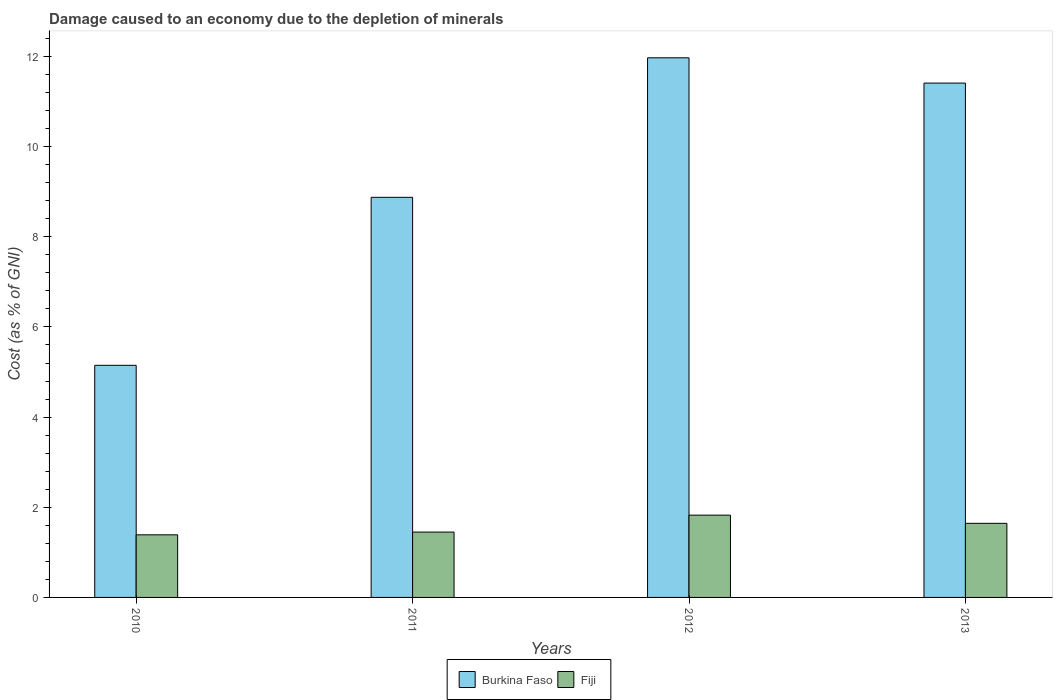Are the number of bars on each tick of the X-axis equal?
Ensure brevity in your answer.  Yes. What is the label of the 1st group of bars from the left?
Make the answer very short. 2010. In how many cases, is the number of bars for a given year not equal to the number of legend labels?
Ensure brevity in your answer.  0. What is the cost of damage caused due to the depletion of minerals in Fiji in 2013?
Provide a short and direct response. 1.64. Across all years, what is the maximum cost of damage caused due to the depletion of minerals in Burkina Faso?
Offer a very short reply. 11.97. Across all years, what is the minimum cost of damage caused due to the depletion of minerals in Fiji?
Your response must be concise. 1.39. In which year was the cost of damage caused due to the depletion of minerals in Burkina Faso maximum?
Keep it short and to the point. 2012. What is the total cost of damage caused due to the depletion of minerals in Fiji in the graph?
Provide a succinct answer. 6.31. What is the difference between the cost of damage caused due to the depletion of minerals in Burkina Faso in 2010 and that in 2012?
Give a very brief answer. -6.82. What is the difference between the cost of damage caused due to the depletion of minerals in Burkina Faso in 2011 and the cost of damage caused due to the depletion of minerals in Fiji in 2012?
Your response must be concise. 7.05. What is the average cost of damage caused due to the depletion of minerals in Burkina Faso per year?
Ensure brevity in your answer.  9.35. In the year 2011, what is the difference between the cost of damage caused due to the depletion of minerals in Fiji and cost of damage caused due to the depletion of minerals in Burkina Faso?
Offer a terse response. -7.43. What is the ratio of the cost of damage caused due to the depletion of minerals in Fiji in 2010 to that in 2012?
Provide a short and direct response. 0.76. Is the cost of damage caused due to the depletion of minerals in Burkina Faso in 2010 less than that in 2012?
Offer a very short reply. Yes. What is the difference between the highest and the second highest cost of damage caused due to the depletion of minerals in Fiji?
Your response must be concise. 0.18. What is the difference between the highest and the lowest cost of damage caused due to the depletion of minerals in Burkina Faso?
Offer a terse response. 6.82. In how many years, is the cost of damage caused due to the depletion of minerals in Burkina Faso greater than the average cost of damage caused due to the depletion of minerals in Burkina Faso taken over all years?
Give a very brief answer. 2. Is the sum of the cost of damage caused due to the depletion of minerals in Fiji in 2012 and 2013 greater than the maximum cost of damage caused due to the depletion of minerals in Burkina Faso across all years?
Your answer should be compact. No. What does the 1st bar from the left in 2013 represents?
Give a very brief answer. Burkina Faso. What does the 2nd bar from the right in 2012 represents?
Your answer should be very brief. Burkina Faso. How many bars are there?
Your response must be concise. 8. Are all the bars in the graph horizontal?
Keep it short and to the point. No. How many years are there in the graph?
Give a very brief answer. 4. Does the graph contain any zero values?
Make the answer very short. No. How are the legend labels stacked?
Provide a short and direct response. Horizontal. What is the title of the graph?
Your answer should be very brief. Damage caused to an economy due to the depletion of minerals. Does "Ireland" appear as one of the legend labels in the graph?
Your answer should be compact. No. What is the label or title of the X-axis?
Keep it short and to the point. Years. What is the label or title of the Y-axis?
Give a very brief answer. Cost (as % of GNI). What is the Cost (as % of GNI) in Burkina Faso in 2010?
Provide a succinct answer. 5.15. What is the Cost (as % of GNI) in Fiji in 2010?
Provide a short and direct response. 1.39. What is the Cost (as % of GNI) in Burkina Faso in 2011?
Give a very brief answer. 8.88. What is the Cost (as % of GNI) in Fiji in 2011?
Your answer should be very brief. 1.45. What is the Cost (as % of GNI) in Burkina Faso in 2012?
Your answer should be very brief. 11.97. What is the Cost (as % of GNI) of Fiji in 2012?
Provide a short and direct response. 1.83. What is the Cost (as % of GNI) of Burkina Faso in 2013?
Keep it short and to the point. 11.41. What is the Cost (as % of GNI) of Fiji in 2013?
Provide a short and direct response. 1.64. Across all years, what is the maximum Cost (as % of GNI) of Burkina Faso?
Provide a short and direct response. 11.97. Across all years, what is the maximum Cost (as % of GNI) of Fiji?
Keep it short and to the point. 1.83. Across all years, what is the minimum Cost (as % of GNI) of Burkina Faso?
Give a very brief answer. 5.15. Across all years, what is the minimum Cost (as % of GNI) in Fiji?
Your answer should be very brief. 1.39. What is the total Cost (as % of GNI) of Burkina Faso in the graph?
Keep it short and to the point. 37.4. What is the total Cost (as % of GNI) in Fiji in the graph?
Provide a short and direct response. 6.31. What is the difference between the Cost (as % of GNI) of Burkina Faso in 2010 and that in 2011?
Offer a terse response. -3.73. What is the difference between the Cost (as % of GNI) of Fiji in 2010 and that in 2011?
Give a very brief answer. -0.06. What is the difference between the Cost (as % of GNI) in Burkina Faso in 2010 and that in 2012?
Give a very brief answer. -6.82. What is the difference between the Cost (as % of GNI) of Fiji in 2010 and that in 2012?
Keep it short and to the point. -0.44. What is the difference between the Cost (as % of GNI) of Burkina Faso in 2010 and that in 2013?
Offer a terse response. -6.26. What is the difference between the Cost (as % of GNI) of Fiji in 2010 and that in 2013?
Offer a very short reply. -0.25. What is the difference between the Cost (as % of GNI) of Burkina Faso in 2011 and that in 2012?
Provide a short and direct response. -3.09. What is the difference between the Cost (as % of GNI) in Fiji in 2011 and that in 2012?
Your answer should be very brief. -0.38. What is the difference between the Cost (as % of GNI) of Burkina Faso in 2011 and that in 2013?
Make the answer very short. -2.53. What is the difference between the Cost (as % of GNI) of Fiji in 2011 and that in 2013?
Your response must be concise. -0.19. What is the difference between the Cost (as % of GNI) of Burkina Faso in 2012 and that in 2013?
Ensure brevity in your answer.  0.56. What is the difference between the Cost (as % of GNI) of Fiji in 2012 and that in 2013?
Ensure brevity in your answer.  0.18. What is the difference between the Cost (as % of GNI) of Burkina Faso in 2010 and the Cost (as % of GNI) of Fiji in 2011?
Your response must be concise. 3.7. What is the difference between the Cost (as % of GNI) in Burkina Faso in 2010 and the Cost (as % of GNI) in Fiji in 2012?
Provide a short and direct response. 3.32. What is the difference between the Cost (as % of GNI) in Burkina Faso in 2010 and the Cost (as % of GNI) in Fiji in 2013?
Provide a short and direct response. 3.51. What is the difference between the Cost (as % of GNI) of Burkina Faso in 2011 and the Cost (as % of GNI) of Fiji in 2012?
Your answer should be compact. 7.05. What is the difference between the Cost (as % of GNI) of Burkina Faso in 2011 and the Cost (as % of GNI) of Fiji in 2013?
Ensure brevity in your answer.  7.23. What is the difference between the Cost (as % of GNI) of Burkina Faso in 2012 and the Cost (as % of GNI) of Fiji in 2013?
Your response must be concise. 10.33. What is the average Cost (as % of GNI) of Burkina Faso per year?
Your response must be concise. 9.35. What is the average Cost (as % of GNI) in Fiji per year?
Your answer should be very brief. 1.58. In the year 2010, what is the difference between the Cost (as % of GNI) in Burkina Faso and Cost (as % of GNI) in Fiji?
Ensure brevity in your answer.  3.76. In the year 2011, what is the difference between the Cost (as % of GNI) of Burkina Faso and Cost (as % of GNI) of Fiji?
Provide a short and direct response. 7.43. In the year 2012, what is the difference between the Cost (as % of GNI) of Burkina Faso and Cost (as % of GNI) of Fiji?
Keep it short and to the point. 10.15. In the year 2013, what is the difference between the Cost (as % of GNI) in Burkina Faso and Cost (as % of GNI) in Fiji?
Your answer should be very brief. 9.77. What is the ratio of the Cost (as % of GNI) in Burkina Faso in 2010 to that in 2011?
Offer a very short reply. 0.58. What is the ratio of the Cost (as % of GNI) in Fiji in 2010 to that in 2011?
Make the answer very short. 0.96. What is the ratio of the Cost (as % of GNI) of Burkina Faso in 2010 to that in 2012?
Provide a succinct answer. 0.43. What is the ratio of the Cost (as % of GNI) in Fiji in 2010 to that in 2012?
Offer a terse response. 0.76. What is the ratio of the Cost (as % of GNI) in Burkina Faso in 2010 to that in 2013?
Your answer should be very brief. 0.45. What is the ratio of the Cost (as % of GNI) of Fiji in 2010 to that in 2013?
Provide a succinct answer. 0.84. What is the ratio of the Cost (as % of GNI) in Burkina Faso in 2011 to that in 2012?
Keep it short and to the point. 0.74. What is the ratio of the Cost (as % of GNI) in Fiji in 2011 to that in 2012?
Offer a terse response. 0.79. What is the ratio of the Cost (as % of GNI) of Burkina Faso in 2011 to that in 2013?
Your response must be concise. 0.78. What is the ratio of the Cost (as % of GNI) in Fiji in 2011 to that in 2013?
Provide a short and direct response. 0.88. What is the ratio of the Cost (as % of GNI) of Burkina Faso in 2012 to that in 2013?
Keep it short and to the point. 1.05. What is the ratio of the Cost (as % of GNI) in Fiji in 2012 to that in 2013?
Provide a succinct answer. 1.11. What is the difference between the highest and the second highest Cost (as % of GNI) of Burkina Faso?
Give a very brief answer. 0.56. What is the difference between the highest and the second highest Cost (as % of GNI) of Fiji?
Provide a succinct answer. 0.18. What is the difference between the highest and the lowest Cost (as % of GNI) of Burkina Faso?
Make the answer very short. 6.82. What is the difference between the highest and the lowest Cost (as % of GNI) in Fiji?
Your answer should be compact. 0.44. 